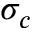<formula> <loc_0><loc_0><loc_500><loc_500>\sigma _ { c }</formula> 